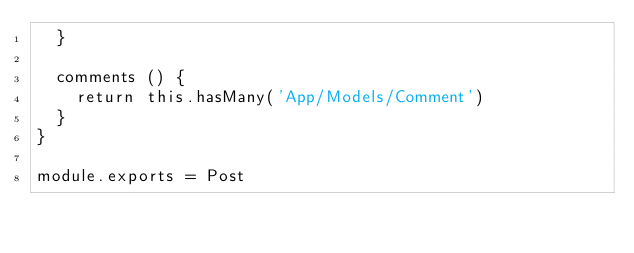Convert code to text. <code><loc_0><loc_0><loc_500><loc_500><_JavaScript_>  }

  comments () {
    return this.hasMany('App/Models/Comment')
  }
}

module.exports = Post
</code> 